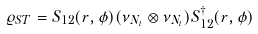Convert formula to latex. <formula><loc_0><loc_0><loc_500><loc_500>\varrho _ { S T } = S _ { 1 2 } ( r , \phi ) ( \nu _ { N _ { t } } \otimes \nu _ { N _ { t } } ) S _ { 1 2 } ^ { \dag } ( r , \phi )</formula> 